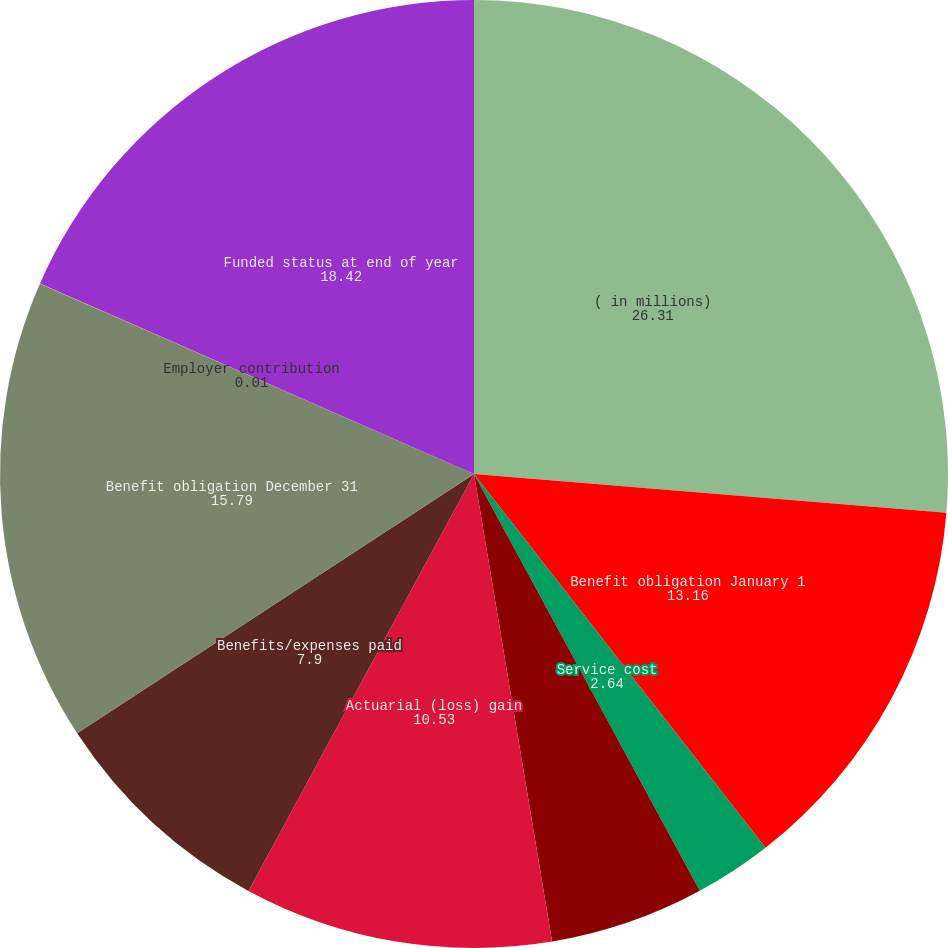Convert chart to OTSL. <chart><loc_0><loc_0><loc_500><loc_500><pie_chart><fcel>( in millions)<fcel>Benefit obligation January 1<fcel>Service cost<fcel>Interest cost<fcel>Actuarial (loss) gain<fcel>Benefits/expenses paid<fcel>Benefit obligation December 31<fcel>Employer contribution<fcel>Funded status at end of year<nl><fcel>26.31%<fcel>13.16%<fcel>2.64%<fcel>5.27%<fcel>10.53%<fcel>7.9%<fcel>15.79%<fcel>0.01%<fcel>18.42%<nl></chart> 